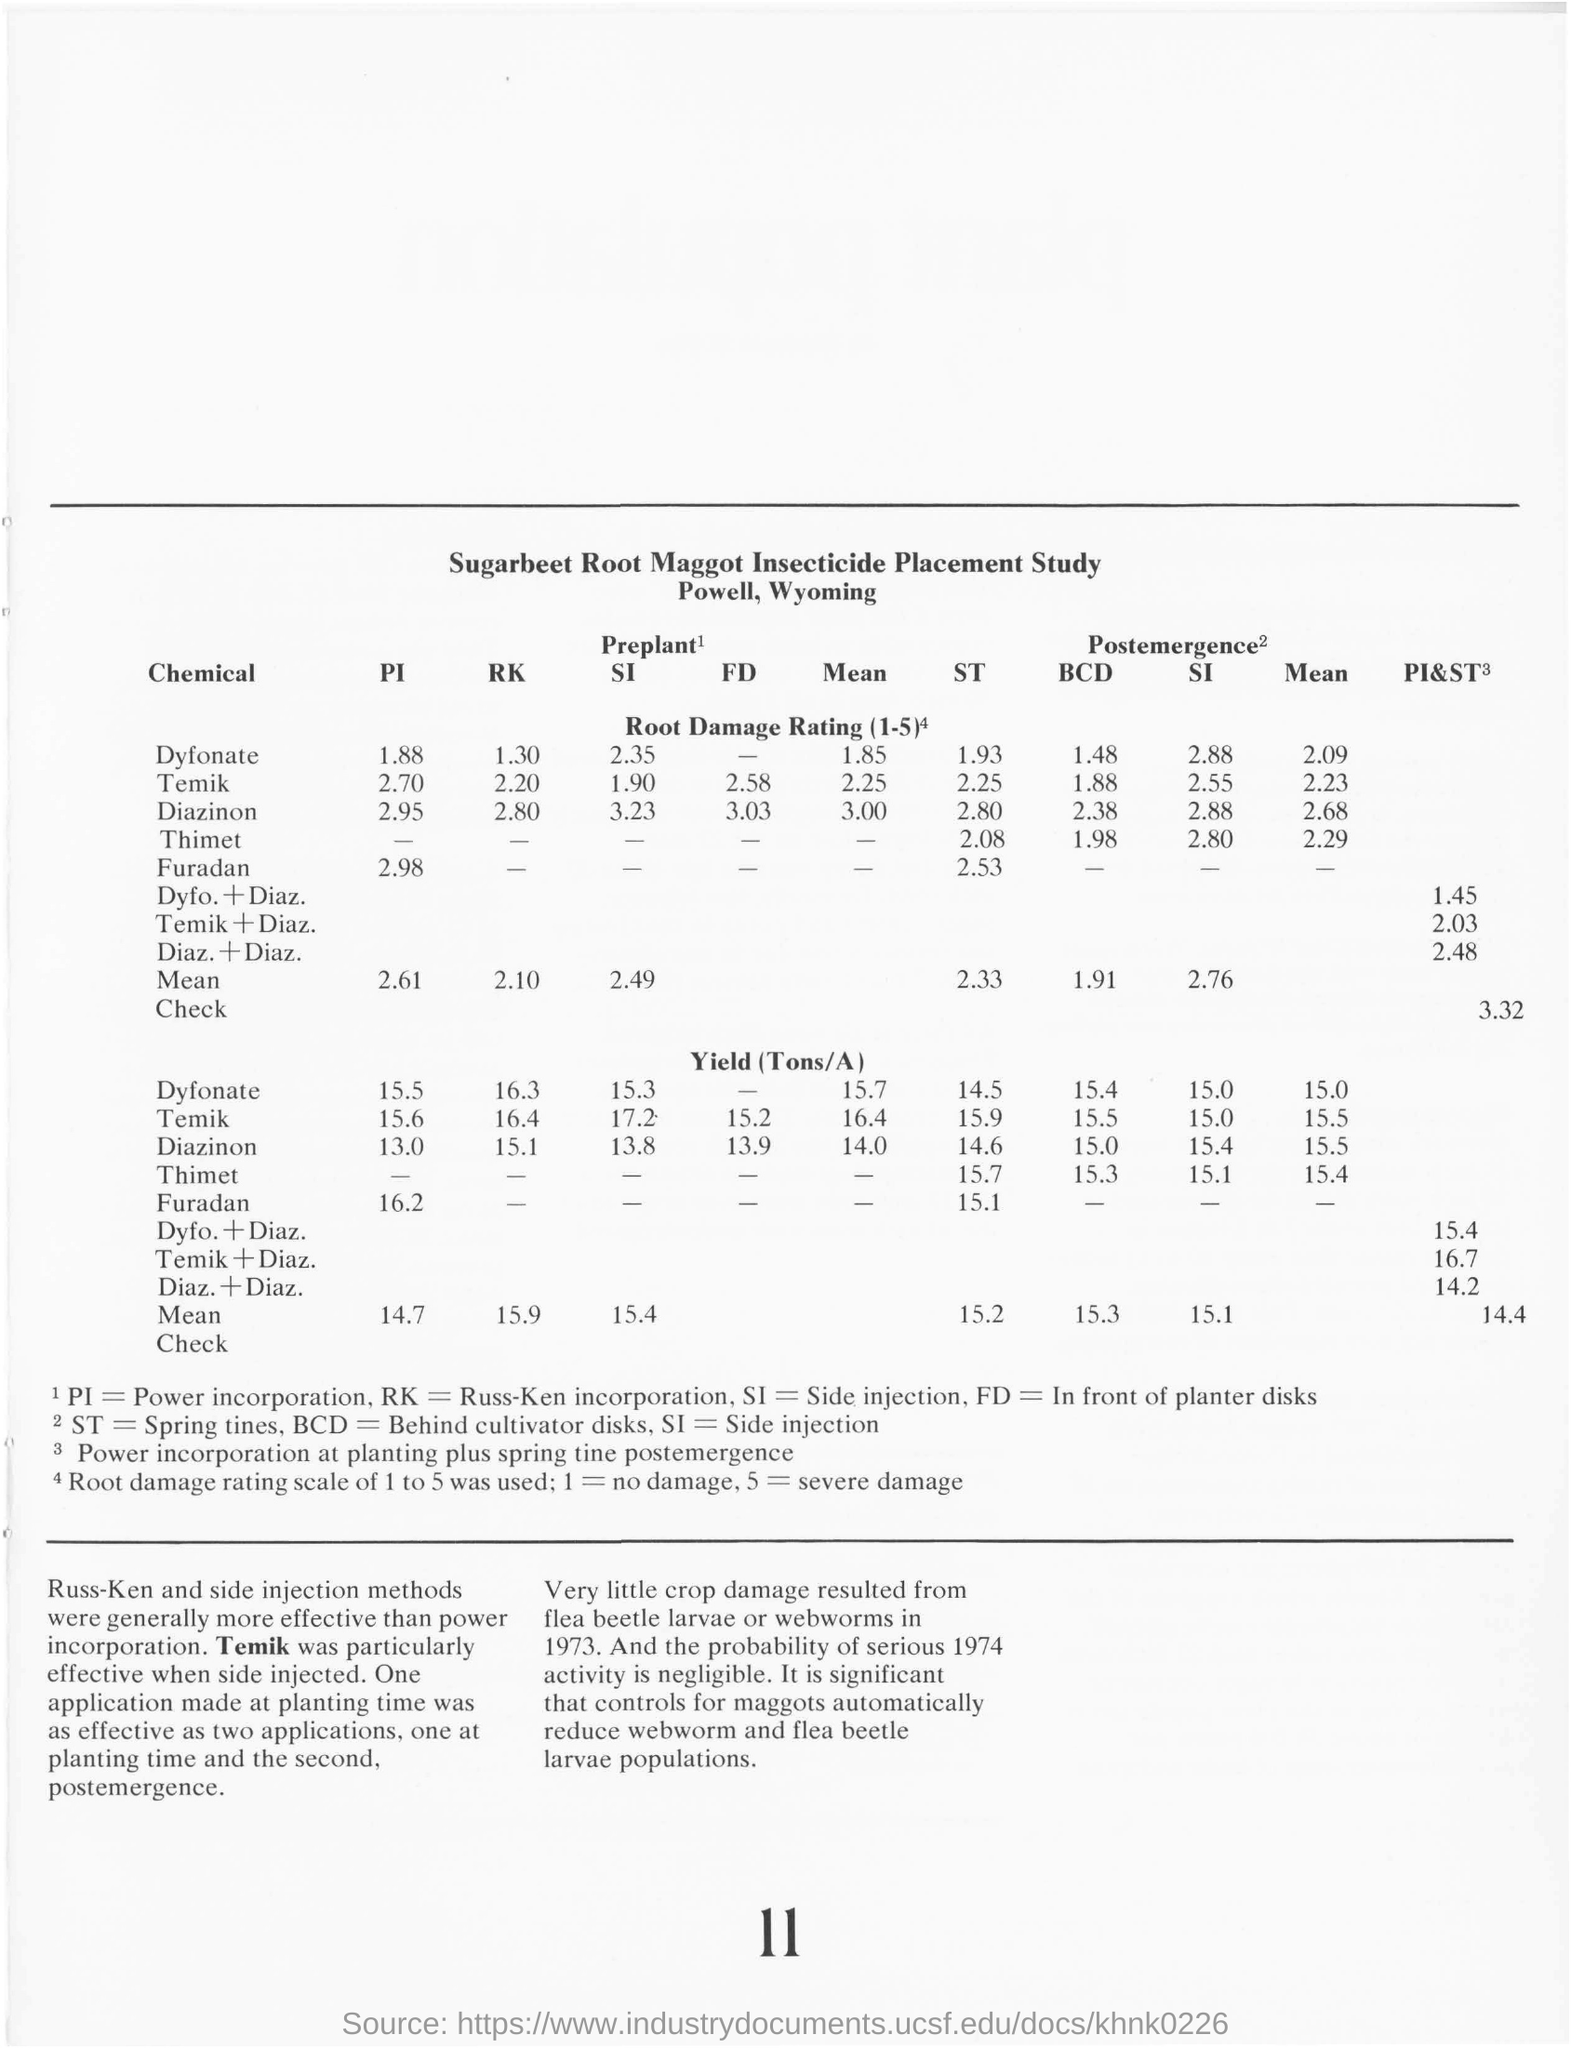What is the yield(Tons/A)  value with use of Dyfonate at preplant time by PI method?
Offer a very short reply. 15.5. What is the yield(Tons/A)value with use of Temik at preplant time by RK method?
Offer a terse response. 16.4. What is the Root Damage Rating for Diazinon by Side Injection method at postemergence time?
Give a very brief answer. 2.88. Which chemical was particularly effective when Side Injected?
Offer a very short reply. Temik. Mention two methods which were more effective than power incorporation.
Give a very brief answer. Russ-Ken and side injection methods. What does BCD stands for?
Provide a short and direct response. Behind Cultivator disks. What is the mean value of Yield(Tons/A) with use of Dyfonate at preplant time?
Your answer should be compact. 15.7. 